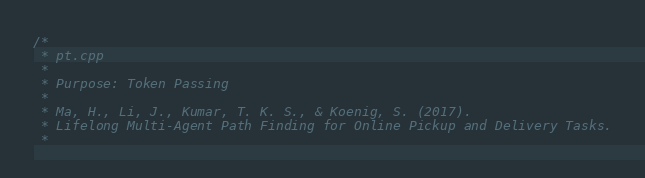Convert code to text. <code><loc_0><loc_0><loc_500><loc_500><_C++_>/*
 * pt.cpp
 *
 * Purpose: Token Passing
 *
 * Ma, H., Li, J., Kumar, T. K. S., & Koenig, S. (2017).
 * Lifelong Multi-Agent Path Finding for Online Pickup and Delivery Tasks.
 *</code> 